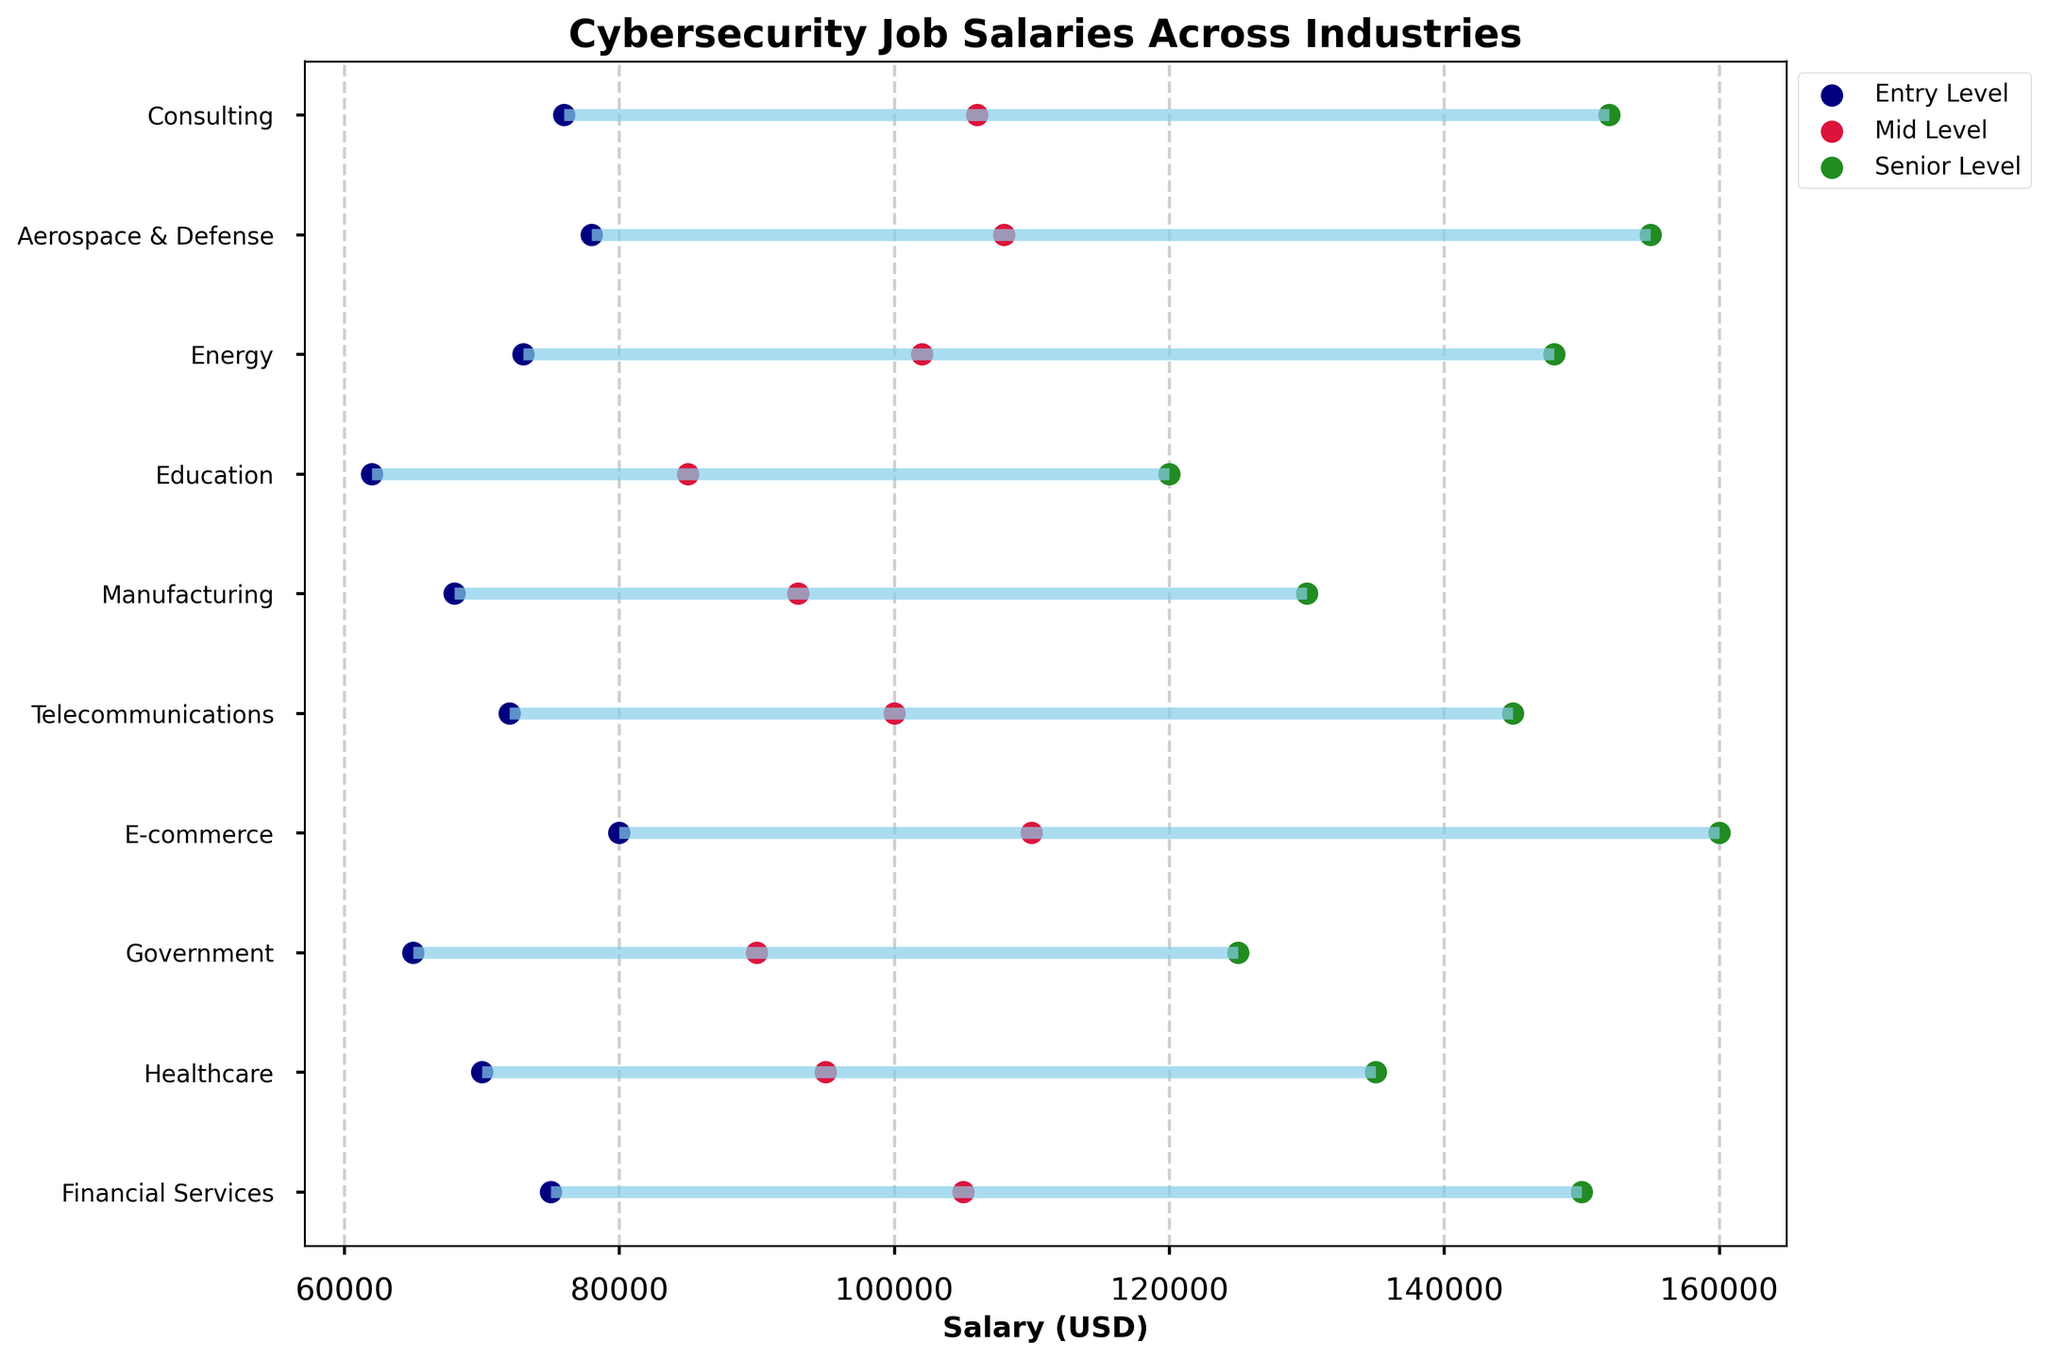What's the title of the plot? The title is typically located at the top of the plot. In this case, it should explicitly highlight the subject of the visualization.
Answer: Cybersecurity Job Salaries Across Industries Which industry has the highest senior-level salary? To find the highest senior-level salary, look at the endpoints of the green dots (representing senior levels) and identify the highest value.
Answer: E-commerce What is the salary range difference between entry-level and senior-level in the Government industry? Check the entry-level and senior-level salaries for the Government industry, then subtract the entry-level salary from the senior-level salary.
Answer: 60,000 (125,000 - 65,000) Which industry offers the highest entry-level salary? Look at all the starting points of the navy-colored dots (representing entry levels), and identify the highest one.
Answer: E-commerce Which experience level in the Financial Services industry offers the salary of 105,000? Locate the Financial Services row and find the corresponding dot with a salary of 105,000. See which color it aligns with.
Answer: Mid Level What is the average mid-level salary across all industries? Add all the mid-level salaries and divide by the total number of industries. (105,000 + 95,000 + 90,000 + 110,000 + 100,000 + 93,000 + 85,000 + 102,000 + 108,000 + 106,000) / 10 = 99,400
Answer: 99,400 Compare the salary range of the Healthcare and Telecommunications industries for senior-level positions. Which has a higher maximum? Identify and compare the endpoint of the green dots for Healthcare and Telecommunications; the higher one has the higher maximum salary.
Answer: Telecommunications Which industry has the smallest gap between entry and senior-level salaries? Calculate the difference between entry and senior-level salaries for each industry and find the smallest gap.
Answer: Education What is the mid-level salary in the Education sector? Find the Education sector row and look for the crimson-colored dot which represents the mid-level salary.
Answer: 85,000 How does the salary range of Aerospace & Defense compare to Energy for senior-level positions? Compare the green dots' endpoints for Aerospace & Defense and Energy to determine which is higher.
Answer: Aerospace & Defense 